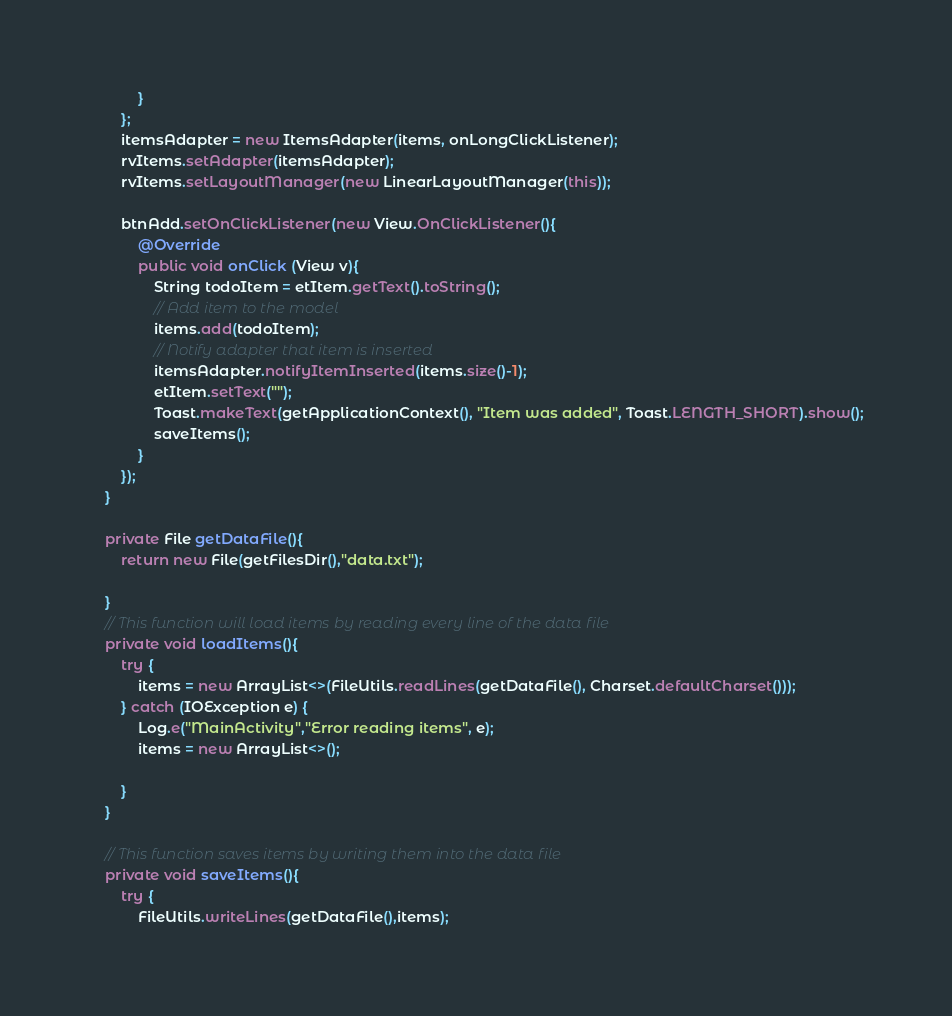Convert code to text. <code><loc_0><loc_0><loc_500><loc_500><_Java_>            }
        };
        itemsAdapter = new ItemsAdapter(items, onLongClickListener);
        rvItems.setAdapter(itemsAdapter);
        rvItems.setLayoutManager(new LinearLayoutManager(this));

        btnAdd.setOnClickListener(new View.OnClickListener(){
            @Override
            public void onClick (View v){
                String todoItem = etItem.getText().toString();
                // Add item to the model
                items.add(todoItem);
                // Notify adapter that item is inserted
                itemsAdapter.notifyItemInserted(items.size()-1);
                etItem.setText("");
                Toast.makeText(getApplicationContext(), "Item was added", Toast.LENGTH_SHORT).show();
                saveItems();
            }
        });
    }

    private File getDataFile(){
        return new File(getFilesDir(),"data.txt");

    }
    // This function will load items by reading every line of the data file
    private void loadItems(){
        try {
            items = new ArrayList<>(FileUtils.readLines(getDataFile(), Charset.defaultCharset()));
        } catch (IOException e) {
            Log.e("MainActivity","Error reading items", e);
            items = new ArrayList<>();

        }
    }

    // This function saves items by writing them into the data file
    private void saveItems(){
        try {
            FileUtils.writeLines(getDataFile(),items);</code> 